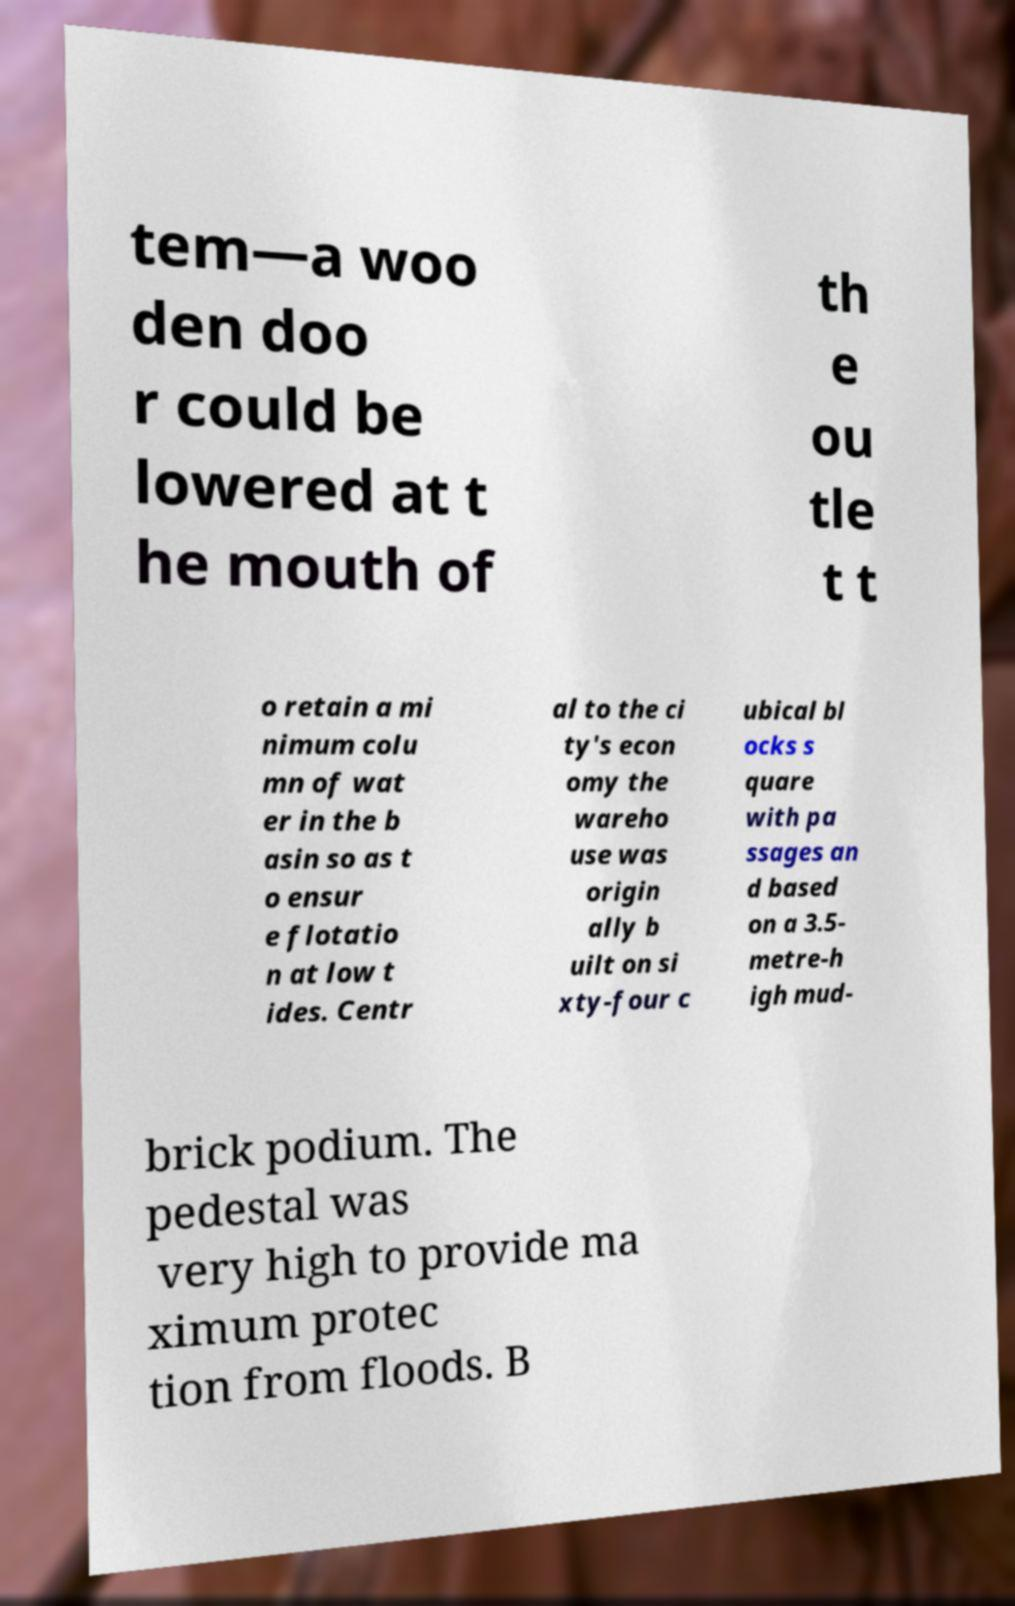Please read and relay the text visible in this image. What does it say? tem—a woo den doo r could be lowered at t he mouth of th e ou tle t t o retain a mi nimum colu mn of wat er in the b asin so as t o ensur e flotatio n at low t ides. Centr al to the ci ty's econ omy the wareho use was origin ally b uilt on si xty-four c ubical bl ocks s quare with pa ssages an d based on a 3.5- metre-h igh mud- brick podium. The pedestal was very high to provide ma ximum protec tion from floods. B 